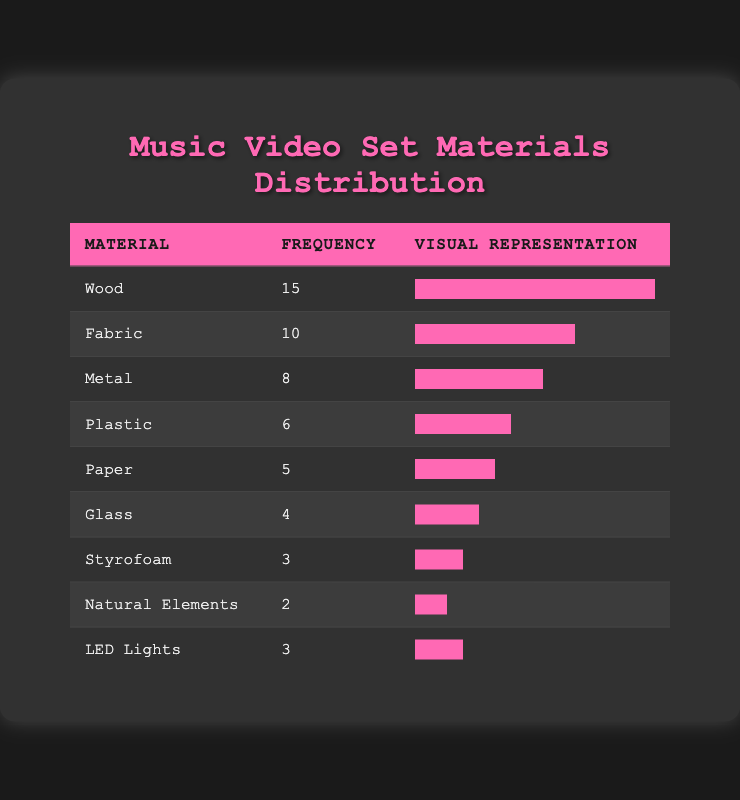What is the most commonly used material for set construction? The material with the highest frequency in the table is Wood, which has a frequency of 15.
Answer: Wood Which material has the least frequency? Looking through the table, Natural Elements has the lowest frequency at 2.
Answer: Natural Elements How many more units of Wood were used compared to Glass? Wood has a frequency of 15, and Glass has a frequency of 4. The difference is 15 - 4 = 11.
Answer: 11 What is the total frequency of all materials listed in the table? By adding all the frequencies: 15 + 10 + 8 + 6 + 5 + 4 + 3 + 2 + 3 = 56.
Answer: 56 Is the frequency of Plastic greater than that of Fabric? Plastic has a frequency of 6, while Fabric has a frequency of 10. Since 6 is less than 10, the answer is no.
Answer: No What is the average frequency of the materials used? To calculate the average, sum all the frequencies (56) and divide by the number of materials (9): 56 / 9 ≈ 6.22.
Answer: 6.22 If we combine the frequencies of Styrofoam and LED Lights, how do they compare to that of Paper? Styrofoam has a frequency of 3 and LED Lights also has a frequency of 3. Combined, they total 3 + 3 = 6. Paper has a frequency of 5, so 6 is greater than 5.
Answer: Yes Which material's frequency is closest to the average frequency? The average frequency calculated earlier is approximately 6.22. Looking through the list, Plastic (6) is closest to the average frequency of 6.22.
Answer: Plastic 